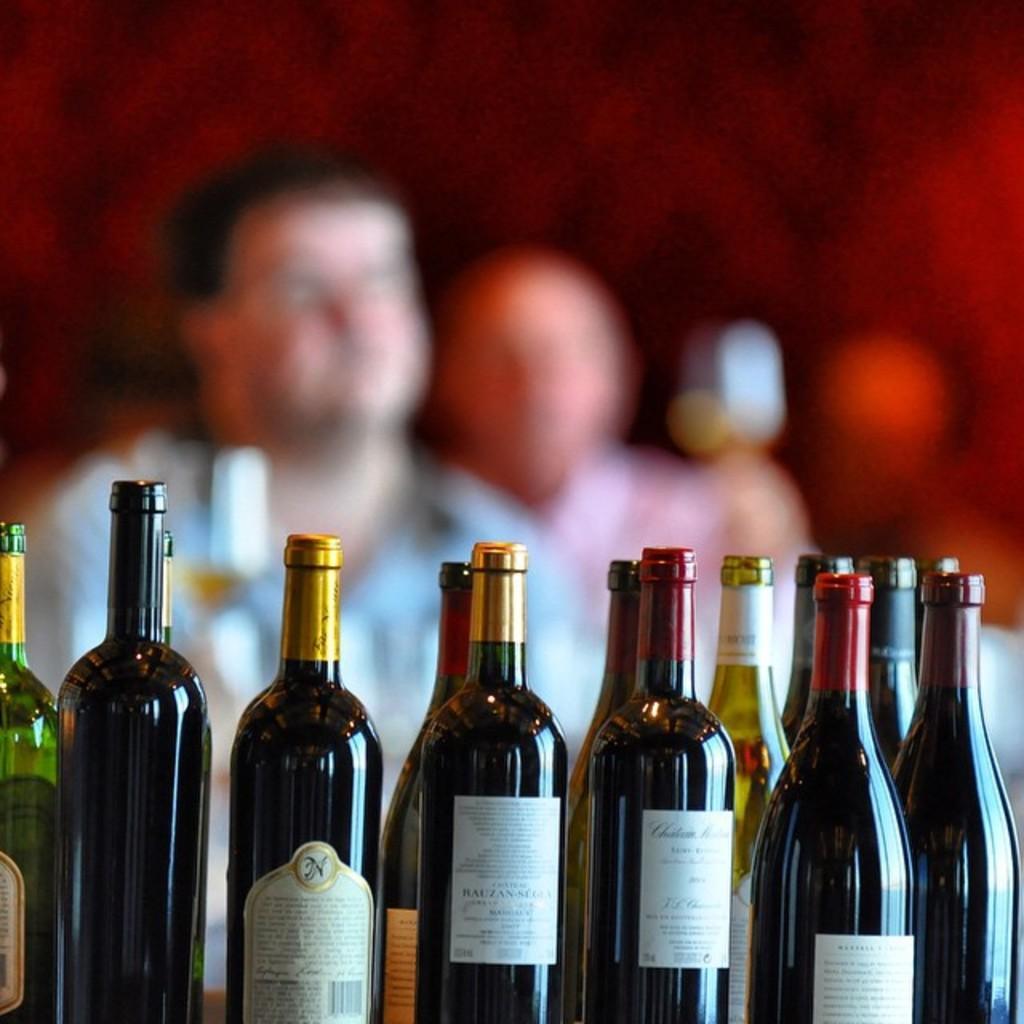How would you summarize this image in a sentence or two? In this image i can see few wine bottles and in the background i can see few people. 